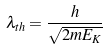<formula> <loc_0><loc_0><loc_500><loc_500>\lambda _ { t h } = \frac { h } { \sqrt { 2 m E _ { K } } }</formula> 